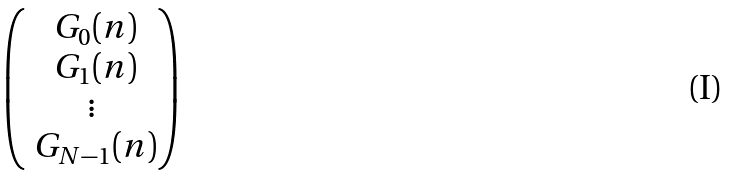Convert formula to latex. <formula><loc_0><loc_0><loc_500><loc_500>\begin{pmatrix} \ G _ { 0 } ( n ) \\ \ G _ { 1 } ( n ) \\ \vdots \\ \ G _ { N - 1 } ( n ) \end{pmatrix}</formula> 